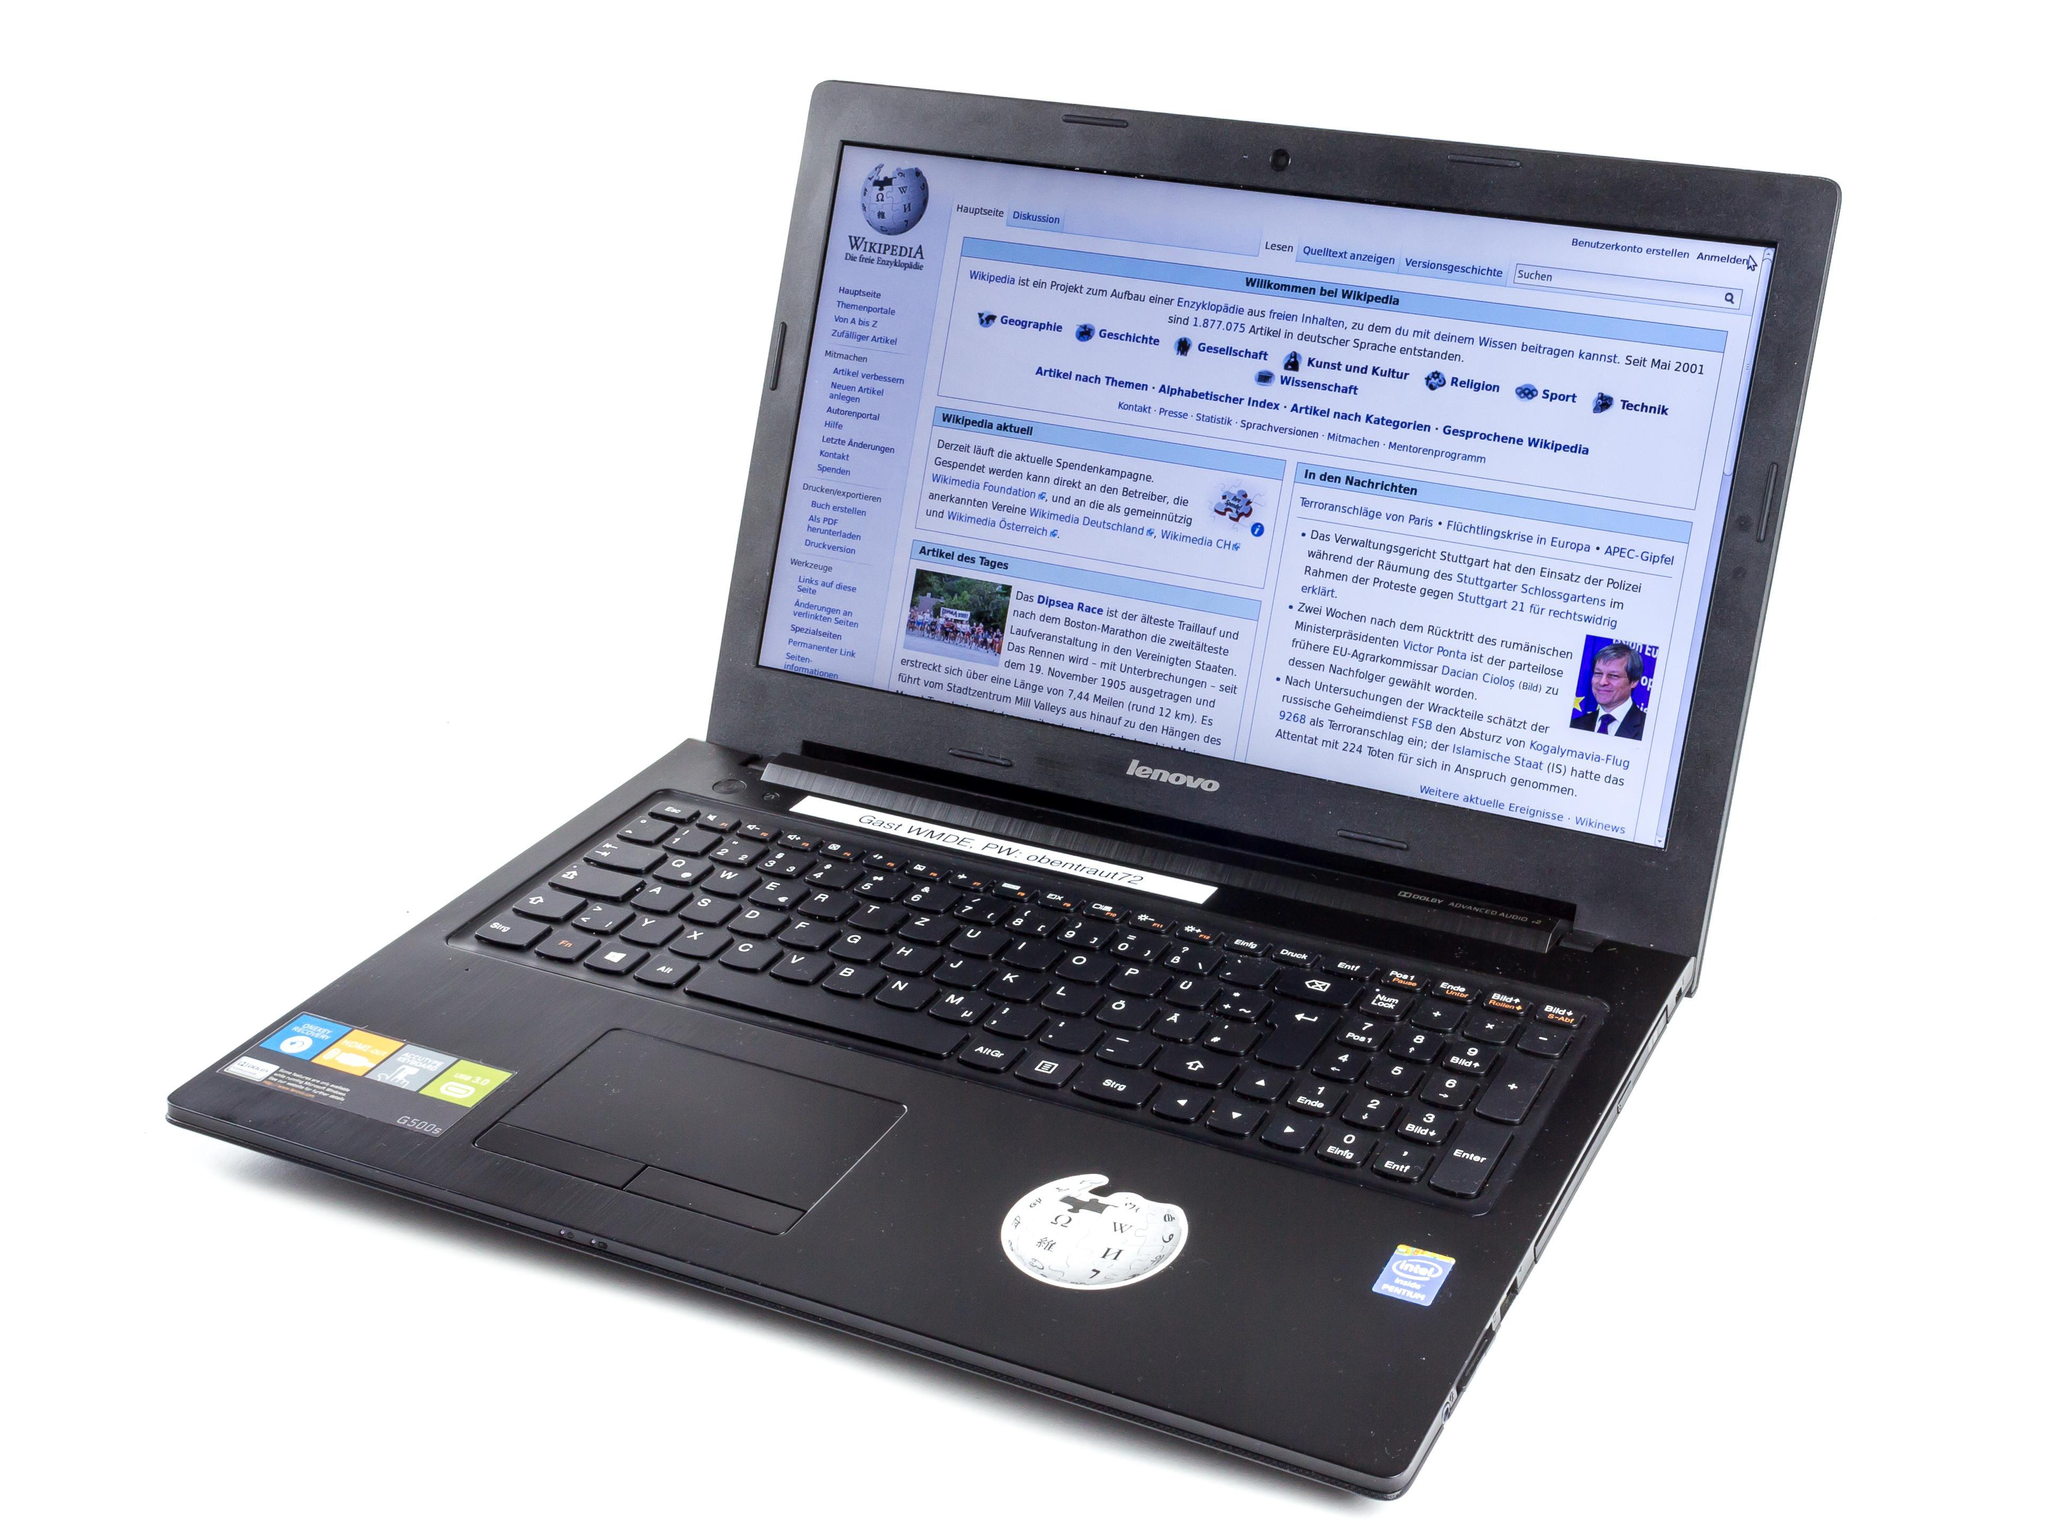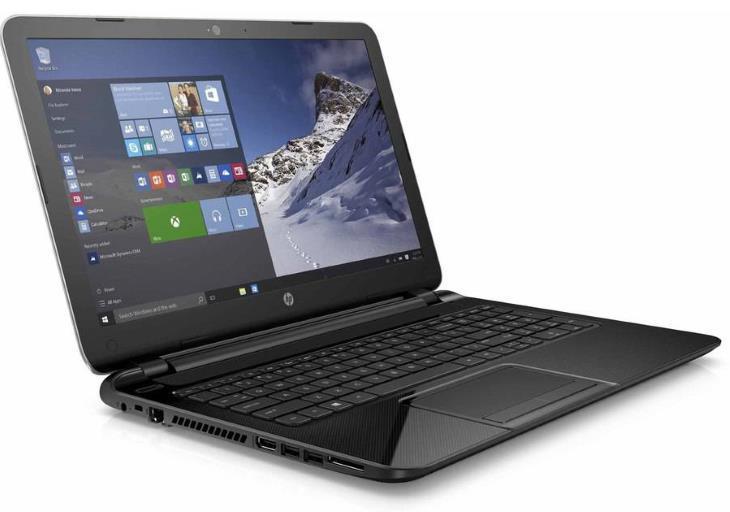The first image is the image on the left, the second image is the image on the right. For the images shown, is this caption "The laptop in the image on the left is facing forward." true? Answer yes or no. No. 